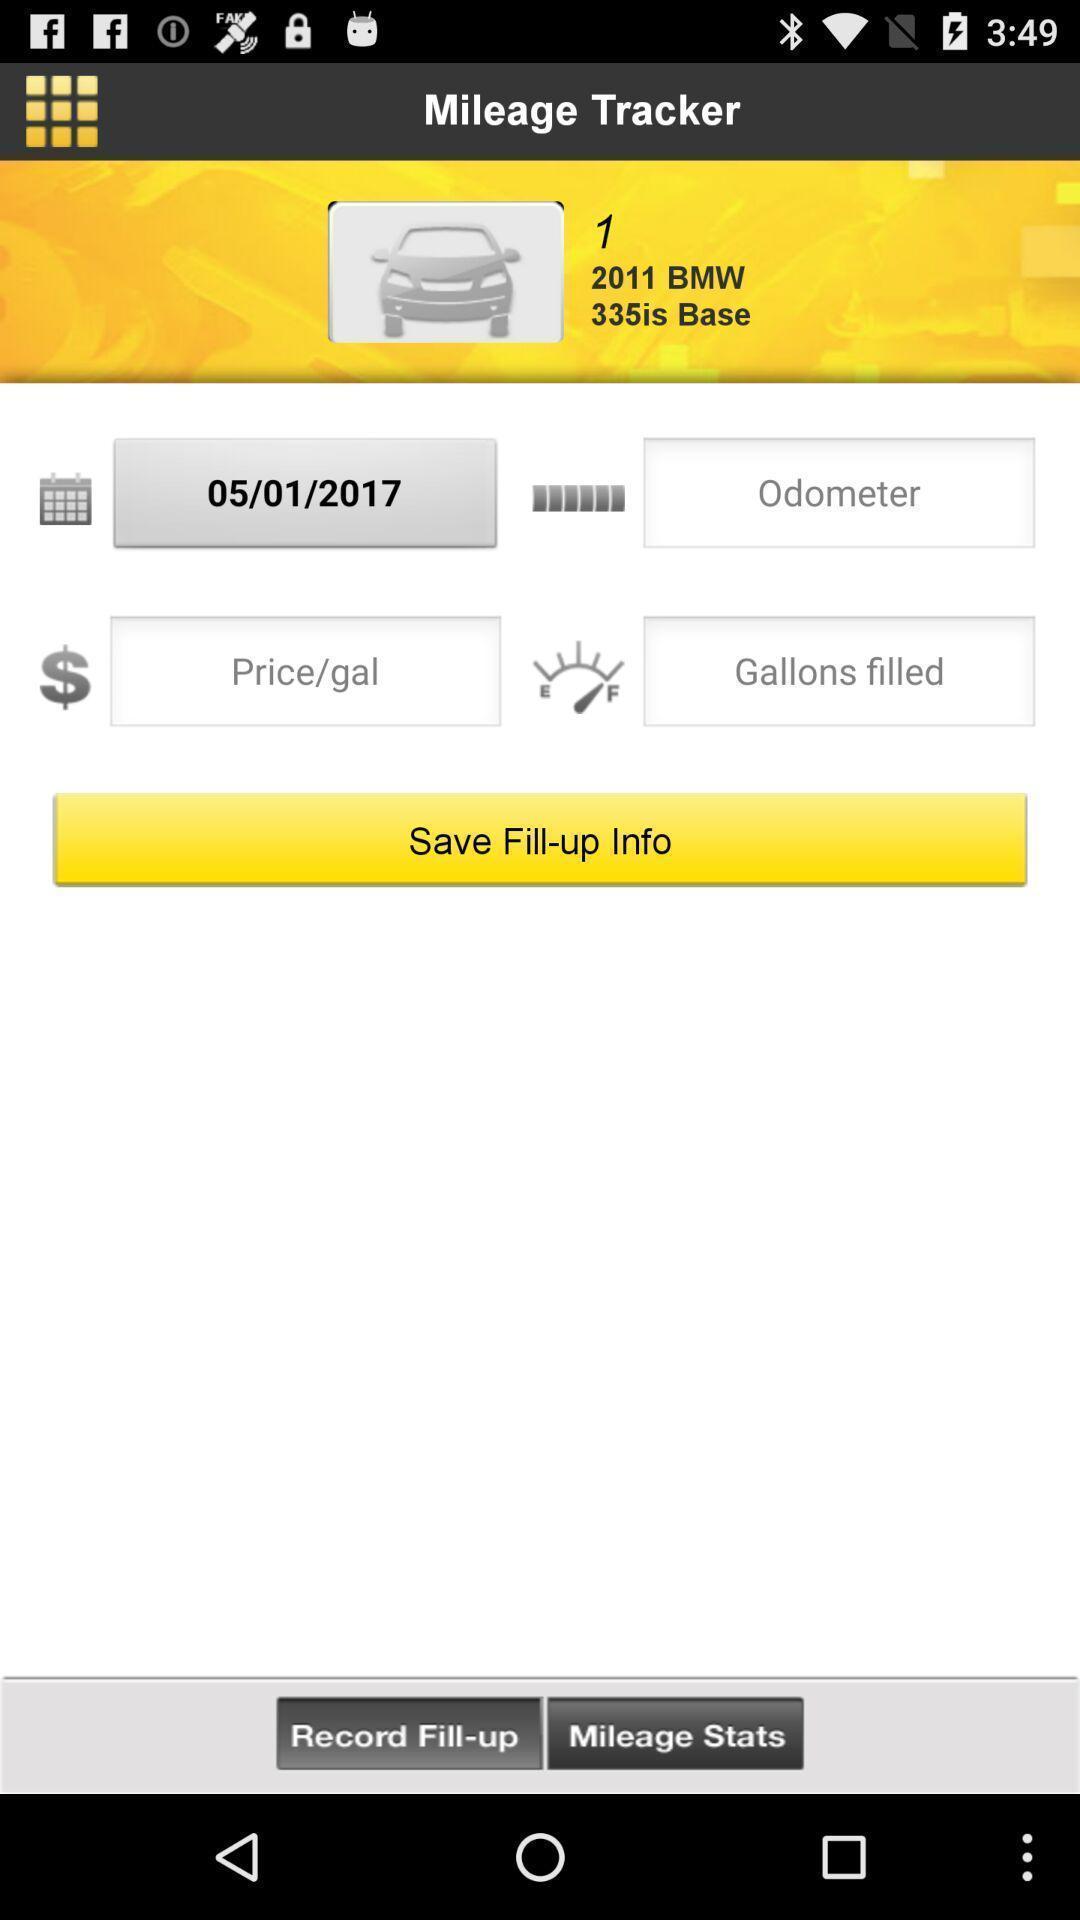Provide a detailed account of this screenshot. Screen displaying multiple vehicle mileage options in a tracking application. 